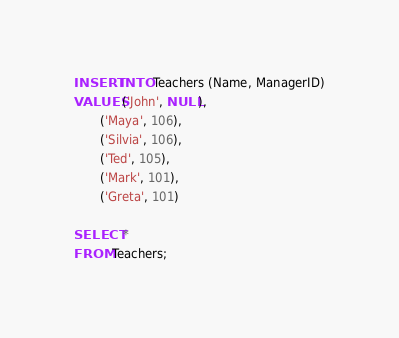<code> <loc_0><loc_0><loc_500><loc_500><_SQL_>INSERT INTO Teachers (Name, ManagerID)
VALUES ('John', NULL),
       ('Maya', 106),
       ('Silvia', 106),
       ('Ted', 105),
       ('Mark', 101),
       ('Greta', 101)

SELECT *
FROM Teachers;</code> 